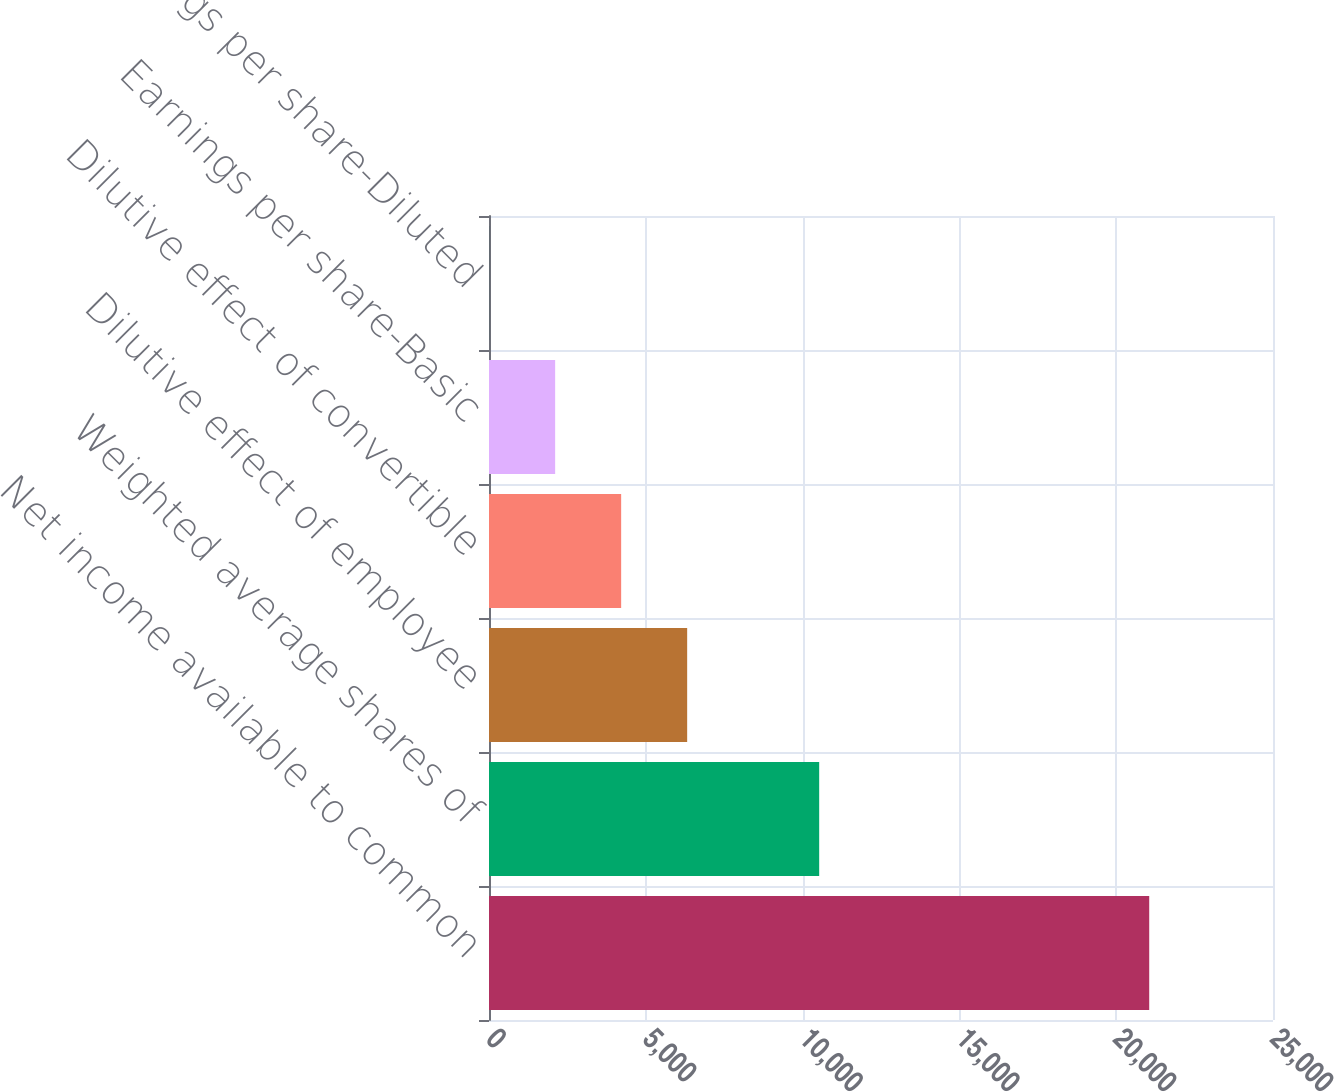Convert chart to OTSL. <chart><loc_0><loc_0><loc_500><loc_500><bar_chart><fcel>Net income available to common<fcel>Weighted average shares of<fcel>Dilutive effect of employee<fcel>Dilutive effect of convertible<fcel>Earnings per share-Basic<fcel>Earnings per share-Diluted<nl><fcel>21053<fcel>10528.7<fcel>6319.03<fcel>4214.18<fcel>2109.33<fcel>4.48<nl></chart> 